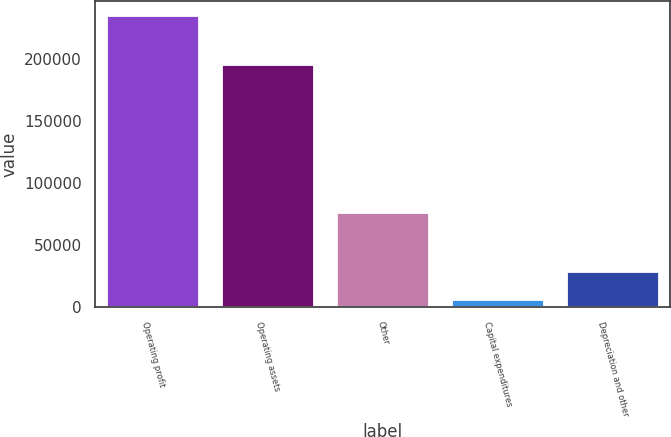<chart> <loc_0><loc_0><loc_500><loc_500><bar_chart><fcel>Operating profit<fcel>Operating assets<fcel>Other<fcel>Capital expenditures<fcel>Depreciation and other<nl><fcel>235018<fcel>195413<fcel>76193<fcel>5707<fcel>28638.1<nl></chart> 